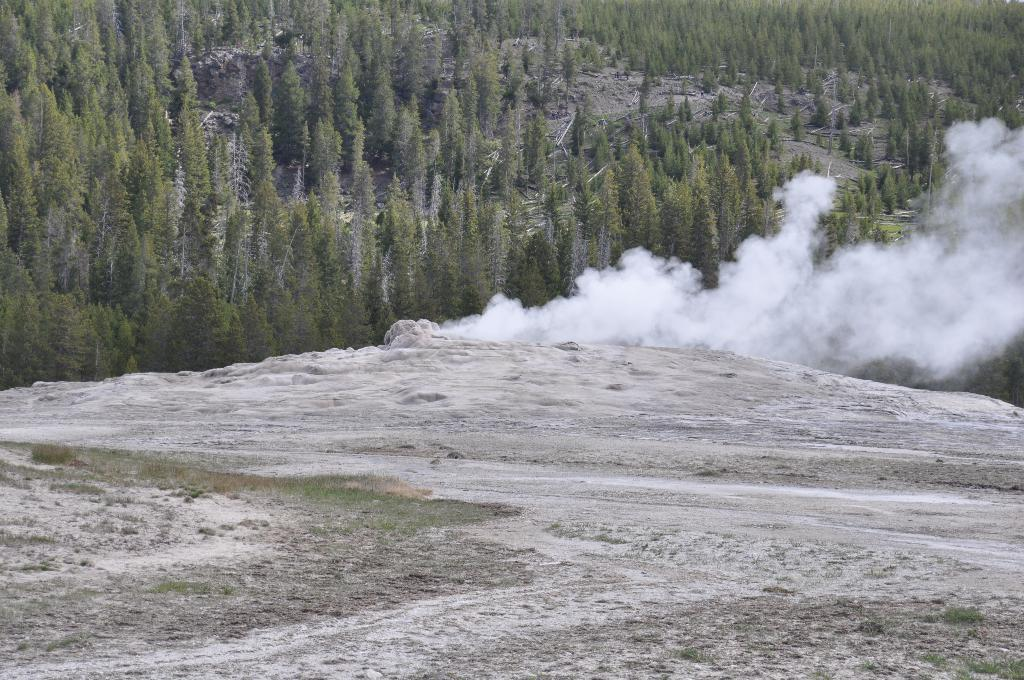What type of surface can be seen in the image? There is ground visible in the image. What is present in the air in the image? There is smoke in the image. What type of vegetation is visible in the background of the image? There are trees in the background of the image. What type of connection can be seen between the trees in the image? There is no connection between the trees in the image; they are separate entities. How many eggs are visible in the image? There are no eggs present in the image. 